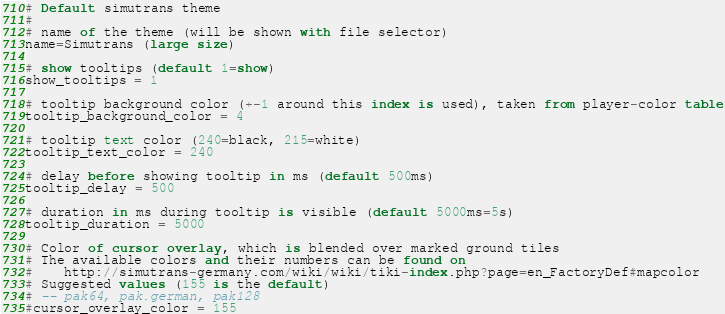<code> <loc_0><loc_0><loc_500><loc_500><_SQL_># Default simutrans theme
#
# name of the theme (will be shown with file selector)
name=Simutrans (large size)

# show tooltips (default 1=show)
show_tooltips = 1

# tooltip background color (+-1 around this index is used), taken from player-color table
tooltip_background_color = 4

# tooltip text color (240=black, 215=white)
tooltip_text_color = 240

# delay before showing tooltip in ms (default 500ms)
tooltip_delay = 500

# duration in ms during tooltip is visible (default 5000ms=5s)
tooltip_duration = 5000

# Color of cursor overlay, which is blended over marked ground tiles
# The available colors and their numbers can be found on
#    http://simutrans-germany.com/wiki/wiki/tiki-index.php?page=en_FactoryDef#mapcolor
# Suggested values (155 is the default)
# -- pak64, pak.german, pak128
#cursor_overlay_color = 155</code> 